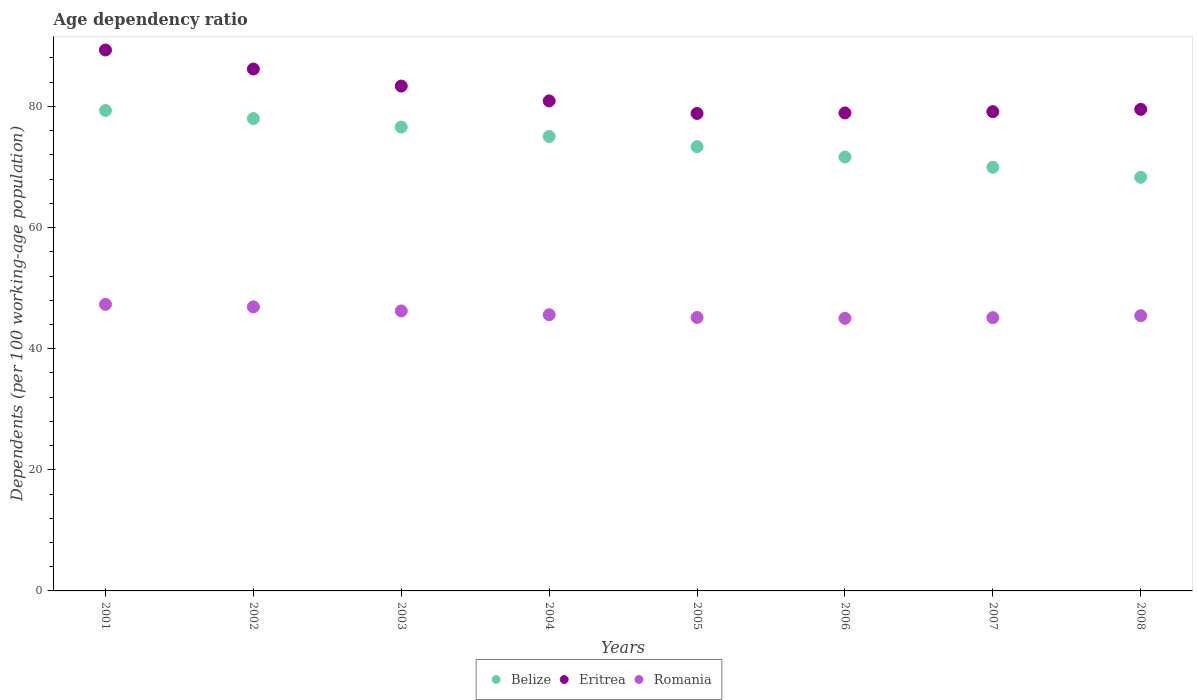How many different coloured dotlines are there?
Provide a short and direct response. 3. What is the age dependency ratio in in Eritrea in 2001?
Provide a succinct answer. 89.32. Across all years, what is the maximum age dependency ratio in in Eritrea?
Offer a very short reply. 89.32. Across all years, what is the minimum age dependency ratio in in Eritrea?
Offer a terse response. 78.84. In which year was the age dependency ratio in in Romania minimum?
Ensure brevity in your answer.  2006. What is the total age dependency ratio in in Romania in the graph?
Offer a terse response. 366.78. What is the difference between the age dependency ratio in in Belize in 2003 and that in 2005?
Your answer should be compact. 3.24. What is the difference between the age dependency ratio in in Romania in 2005 and the age dependency ratio in in Belize in 2008?
Provide a short and direct response. -23.15. What is the average age dependency ratio in in Romania per year?
Your response must be concise. 45.85. In the year 2008, what is the difference between the age dependency ratio in in Romania and age dependency ratio in in Belize?
Your response must be concise. -22.85. What is the ratio of the age dependency ratio in in Belize in 2005 to that in 2007?
Offer a terse response. 1.05. Is the age dependency ratio in in Romania in 2001 less than that in 2007?
Make the answer very short. No. What is the difference between the highest and the second highest age dependency ratio in in Romania?
Give a very brief answer. 0.43. What is the difference between the highest and the lowest age dependency ratio in in Romania?
Ensure brevity in your answer.  2.32. Is the sum of the age dependency ratio in in Romania in 2004 and 2008 greater than the maximum age dependency ratio in in Eritrea across all years?
Ensure brevity in your answer.  Yes. Does the age dependency ratio in in Belize monotonically increase over the years?
Ensure brevity in your answer.  No. Is the age dependency ratio in in Eritrea strictly less than the age dependency ratio in in Romania over the years?
Provide a succinct answer. No. How many dotlines are there?
Your answer should be compact. 3. How many years are there in the graph?
Give a very brief answer. 8. What is the difference between two consecutive major ticks on the Y-axis?
Offer a very short reply. 20. Does the graph contain any zero values?
Provide a succinct answer. No. Does the graph contain grids?
Your answer should be compact. No. How many legend labels are there?
Your answer should be compact. 3. How are the legend labels stacked?
Provide a short and direct response. Horizontal. What is the title of the graph?
Your answer should be compact. Age dependency ratio. What is the label or title of the X-axis?
Give a very brief answer. Years. What is the label or title of the Y-axis?
Your answer should be very brief. Dependents (per 100 working-age population). What is the Dependents (per 100 working-age population) in Belize in 2001?
Keep it short and to the point. 79.32. What is the Dependents (per 100 working-age population) in Eritrea in 2001?
Your answer should be compact. 89.32. What is the Dependents (per 100 working-age population) of Romania in 2001?
Make the answer very short. 47.32. What is the Dependents (per 100 working-age population) in Belize in 2002?
Provide a short and direct response. 77.99. What is the Dependents (per 100 working-age population) of Eritrea in 2002?
Ensure brevity in your answer.  86.18. What is the Dependents (per 100 working-age population) of Romania in 2002?
Offer a terse response. 46.9. What is the Dependents (per 100 working-age population) of Belize in 2003?
Your response must be concise. 76.59. What is the Dependents (per 100 working-age population) of Eritrea in 2003?
Make the answer very short. 83.36. What is the Dependents (per 100 working-age population) in Romania in 2003?
Your answer should be compact. 46.23. What is the Dependents (per 100 working-age population) in Belize in 2004?
Provide a succinct answer. 75.04. What is the Dependents (per 100 working-age population) in Eritrea in 2004?
Provide a short and direct response. 80.91. What is the Dependents (per 100 working-age population) of Romania in 2004?
Provide a short and direct response. 45.61. What is the Dependents (per 100 working-age population) in Belize in 2005?
Offer a very short reply. 73.35. What is the Dependents (per 100 working-age population) of Eritrea in 2005?
Your answer should be very brief. 78.84. What is the Dependents (per 100 working-age population) in Romania in 2005?
Offer a terse response. 45.15. What is the Dependents (per 100 working-age population) in Belize in 2006?
Offer a terse response. 71.64. What is the Dependents (per 100 working-age population) in Eritrea in 2006?
Your answer should be compact. 78.92. What is the Dependents (per 100 working-age population) in Romania in 2006?
Provide a succinct answer. 45. What is the Dependents (per 100 working-age population) in Belize in 2007?
Give a very brief answer. 69.95. What is the Dependents (per 100 working-age population) in Eritrea in 2007?
Keep it short and to the point. 79.14. What is the Dependents (per 100 working-age population) in Romania in 2007?
Your response must be concise. 45.12. What is the Dependents (per 100 working-age population) of Belize in 2008?
Keep it short and to the point. 68.3. What is the Dependents (per 100 working-age population) in Eritrea in 2008?
Your response must be concise. 79.51. What is the Dependents (per 100 working-age population) of Romania in 2008?
Your answer should be compact. 45.45. Across all years, what is the maximum Dependents (per 100 working-age population) in Belize?
Your answer should be very brief. 79.32. Across all years, what is the maximum Dependents (per 100 working-age population) of Eritrea?
Provide a short and direct response. 89.32. Across all years, what is the maximum Dependents (per 100 working-age population) in Romania?
Offer a terse response. 47.32. Across all years, what is the minimum Dependents (per 100 working-age population) in Belize?
Ensure brevity in your answer.  68.3. Across all years, what is the minimum Dependents (per 100 working-age population) in Eritrea?
Provide a succinct answer. 78.84. Across all years, what is the minimum Dependents (per 100 working-age population) in Romania?
Your answer should be very brief. 45. What is the total Dependents (per 100 working-age population) of Belize in the graph?
Your answer should be compact. 592.2. What is the total Dependents (per 100 working-age population) of Eritrea in the graph?
Give a very brief answer. 656.19. What is the total Dependents (per 100 working-age population) of Romania in the graph?
Provide a succinct answer. 366.78. What is the difference between the Dependents (per 100 working-age population) in Belize in 2001 and that in 2002?
Your response must be concise. 1.33. What is the difference between the Dependents (per 100 working-age population) in Eritrea in 2001 and that in 2002?
Offer a very short reply. 3.14. What is the difference between the Dependents (per 100 working-age population) of Romania in 2001 and that in 2002?
Offer a very short reply. 0.43. What is the difference between the Dependents (per 100 working-age population) in Belize in 2001 and that in 2003?
Your response must be concise. 2.73. What is the difference between the Dependents (per 100 working-age population) of Eritrea in 2001 and that in 2003?
Your answer should be very brief. 5.96. What is the difference between the Dependents (per 100 working-age population) of Romania in 2001 and that in 2003?
Offer a very short reply. 1.09. What is the difference between the Dependents (per 100 working-age population) in Belize in 2001 and that in 2004?
Your answer should be compact. 4.28. What is the difference between the Dependents (per 100 working-age population) in Eritrea in 2001 and that in 2004?
Your response must be concise. 8.41. What is the difference between the Dependents (per 100 working-age population) in Romania in 2001 and that in 2004?
Ensure brevity in your answer.  1.72. What is the difference between the Dependents (per 100 working-age population) of Belize in 2001 and that in 2005?
Your answer should be compact. 5.97. What is the difference between the Dependents (per 100 working-age population) in Eritrea in 2001 and that in 2005?
Your answer should be very brief. 10.48. What is the difference between the Dependents (per 100 working-age population) in Romania in 2001 and that in 2005?
Provide a succinct answer. 2.17. What is the difference between the Dependents (per 100 working-age population) of Belize in 2001 and that in 2006?
Ensure brevity in your answer.  7.68. What is the difference between the Dependents (per 100 working-age population) of Eritrea in 2001 and that in 2006?
Make the answer very short. 10.39. What is the difference between the Dependents (per 100 working-age population) in Romania in 2001 and that in 2006?
Offer a terse response. 2.32. What is the difference between the Dependents (per 100 working-age population) of Belize in 2001 and that in 2007?
Ensure brevity in your answer.  9.37. What is the difference between the Dependents (per 100 working-age population) in Eritrea in 2001 and that in 2007?
Ensure brevity in your answer.  10.18. What is the difference between the Dependents (per 100 working-age population) of Romania in 2001 and that in 2007?
Give a very brief answer. 2.2. What is the difference between the Dependents (per 100 working-age population) in Belize in 2001 and that in 2008?
Your response must be concise. 11.02. What is the difference between the Dependents (per 100 working-age population) in Eritrea in 2001 and that in 2008?
Provide a short and direct response. 9.81. What is the difference between the Dependents (per 100 working-age population) in Romania in 2001 and that in 2008?
Offer a very short reply. 1.88. What is the difference between the Dependents (per 100 working-age population) of Belize in 2002 and that in 2003?
Offer a terse response. 1.4. What is the difference between the Dependents (per 100 working-age population) in Eritrea in 2002 and that in 2003?
Provide a succinct answer. 2.82. What is the difference between the Dependents (per 100 working-age population) of Romania in 2002 and that in 2003?
Keep it short and to the point. 0.66. What is the difference between the Dependents (per 100 working-age population) of Belize in 2002 and that in 2004?
Your answer should be compact. 2.95. What is the difference between the Dependents (per 100 working-age population) in Eritrea in 2002 and that in 2004?
Offer a terse response. 5.26. What is the difference between the Dependents (per 100 working-age population) in Romania in 2002 and that in 2004?
Your answer should be very brief. 1.29. What is the difference between the Dependents (per 100 working-age population) of Belize in 2002 and that in 2005?
Offer a terse response. 4.64. What is the difference between the Dependents (per 100 working-age population) of Eritrea in 2002 and that in 2005?
Make the answer very short. 7.34. What is the difference between the Dependents (per 100 working-age population) in Romania in 2002 and that in 2005?
Make the answer very short. 1.75. What is the difference between the Dependents (per 100 working-age population) of Belize in 2002 and that in 2006?
Provide a short and direct response. 6.35. What is the difference between the Dependents (per 100 working-age population) of Eritrea in 2002 and that in 2006?
Provide a succinct answer. 7.25. What is the difference between the Dependents (per 100 working-age population) in Romania in 2002 and that in 2006?
Your answer should be compact. 1.89. What is the difference between the Dependents (per 100 working-age population) in Belize in 2002 and that in 2007?
Provide a succinct answer. 8.05. What is the difference between the Dependents (per 100 working-age population) in Eritrea in 2002 and that in 2007?
Provide a short and direct response. 7.04. What is the difference between the Dependents (per 100 working-age population) of Romania in 2002 and that in 2007?
Offer a very short reply. 1.78. What is the difference between the Dependents (per 100 working-age population) in Belize in 2002 and that in 2008?
Your answer should be very brief. 9.7. What is the difference between the Dependents (per 100 working-age population) in Eritrea in 2002 and that in 2008?
Your answer should be very brief. 6.67. What is the difference between the Dependents (per 100 working-age population) in Romania in 2002 and that in 2008?
Provide a succinct answer. 1.45. What is the difference between the Dependents (per 100 working-age population) of Belize in 2003 and that in 2004?
Keep it short and to the point. 1.55. What is the difference between the Dependents (per 100 working-age population) in Eritrea in 2003 and that in 2004?
Offer a terse response. 2.45. What is the difference between the Dependents (per 100 working-age population) in Romania in 2003 and that in 2004?
Ensure brevity in your answer.  0.63. What is the difference between the Dependents (per 100 working-age population) in Belize in 2003 and that in 2005?
Your answer should be very brief. 3.24. What is the difference between the Dependents (per 100 working-age population) of Eritrea in 2003 and that in 2005?
Your answer should be very brief. 4.52. What is the difference between the Dependents (per 100 working-age population) of Romania in 2003 and that in 2005?
Make the answer very short. 1.08. What is the difference between the Dependents (per 100 working-age population) of Belize in 2003 and that in 2006?
Ensure brevity in your answer.  4.95. What is the difference between the Dependents (per 100 working-age population) in Eritrea in 2003 and that in 2006?
Provide a short and direct response. 4.44. What is the difference between the Dependents (per 100 working-age population) of Romania in 2003 and that in 2006?
Give a very brief answer. 1.23. What is the difference between the Dependents (per 100 working-age population) of Belize in 2003 and that in 2007?
Offer a very short reply. 6.65. What is the difference between the Dependents (per 100 working-age population) of Eritrea in 2003 and that in 2007?
Provide a short and direct response. 4.22. What is the difference between the Dependents (per 100 working-age population) of Romania in 2003 and that in 2007?
Your response must be concise. 1.11. What is the difference between the Dependents (per 100 working-age population) in Belize in 2003 and that in 2008?
Your answer should be very brief. 8.3. What is the difference between the Dependents (per 100 working-age population) in Eritrea in 2003 and that in 2008?
Your answer should be very brief. 3.85. What is the difference between the Dependents (per 100 working-age population) of Romania in 2003 and that in 2008?
Your answer should be compact. 0.79. What is the difference between the Dependents (per 100 working-age population) of Belize in 2004 and that in 2005?
Ensure brevity in your answer.  1.69. What is the difference between the Dependents (per 100 working-age population) of Eritrea in 2004 and that in 2005?
Your answer should be compact. 2.07. What is the difference between the Dependents (per 100 working-age population) in Romania in 2004 and that in 2005?
Offer a terse response. 0.45. What is the difference between the Dependents (per 100 working-age population) in Belize in 2004 and that in 2006?
Offer a very short reply. 3.4. What is the difference between the Dependents (per 100 working-age population) in Eritrea in 2004 and that in 2006?
Provide a short and direct response. 1.99. What is the difference between the Dependents (per 100 working-age population) of Romania in 2004 and that in 2006?
Offer a very short reply. 0.6. What is the difference between the Dependents (per 100 working-age population) of Belize in 2004 and that in 2007?
Make the answer very short. 5.1. What is the difference between the Dependents (per 100 working-age population) of Eritrea in 2004 and that in 2007?
Provide a succinct answer. 1.78. What is the difference between the Dependents (per 100 working-age population) of Romania in 2004 and that in 2007?
Your response must be concise. 0.48. What is the difference between the Dependents (per 100 working-age population) in Belize in 2004 and that in 2008?
Offer a terse response. 6.75. What is the difference between the Dependents (per 100 working-age population) of Eritrea in 2004 and that in 2008?
Keep it short and to the point. 1.4. What is the difference between the Dependents (per 100 working-age population) in Romania in 2004 and that in 2008?
Your answer should be compact. 0.16. What is the difference between the Dependents (per 100 working-age population) in Belize in 2005 and that in 2006?
Offer a terse response. 1.71. What is the difference between the Dependents (per 100 working-age population) in Eritrea in 2005 and that in 2006?
Offer a very short reply. -0.08. What is the difference between the Dependents (per 100 working-age population) of Romania in 2005 and that in 2006?
Make the answer very short. 0.15. What is the difference between the Dependents (per 100 working-age population) of Belize in 2005 and that in 2007?
Offer a terse response. 3.41. What is the difference between the Dependents (per 100 working-age population) of Eritrea in 2005 and that in 2007?
Give a very brief answer. -0.3. What is the difference between the Dependents (per 100 working-age population) in Romania in 2005 and that in 2007?
Offer a terse response. 0.03. What is the difference between the Dependents (per 100 working-age population) in Belize in 2005 and that in 2008?
Provide a short and direct response. 5.05. What is the difference between the Dependents (per 100 working-age population) in Eritrea in 2005 and that in 2008?
Provide a succinct answer. -0.67. What is the difference between the Dependents (per 100 working-age population) in Romania in 2005 and that in 2008?
Your answer should be very brief. -0.3. What is the difference between the Dependents (per 100 working-age population) of Belize in 2006 and that in 2007?
Your answer should be very brief. 1.7. What is the difference between the Dependents (per 100 working-age population) of Eritrea in 2006 and that in 2007?
Provide a short and direct response. -0.21. What is the difference between the Dependents (per 100 working-age population) in Romania in 2006 and that in 2007?
Your answer should be compact. -0.12. What is the difference between the Dependents (per 100 working-age population) in Belize in 2006 and that in 2008?
Offer a very short reply. 3.35. What is the difference between the Dependents (per 100 working-age population) in Eritrea in 2006 and that in 2008?
Your answer should be compact. -0.59. What is the difference between the Dependents (per 100 working-age population) in Romania in 2006 and that in 2008?
Provide a succinct answer. -0.44. What is the difference between the Dependents (per 100 working-age population) in Belize in 2007 and that in 2008?
Offer a very short reply. 1.65. What is the difference between the Dependents (per 100 working-age population) in Eritrea in 2007 and that in 2008?
Provide a succinct answer. -0.37. What is the difference between the Dependents (per 100 working-age population) in Romania in 2007 and that in 2008?
Give a very brief answer. -0.32. What is the difference between the Dependents (per 100 working-age population) in Belize in 2001 and the Dependents (per 100 working-age population) in Eritrea in 2002?
Your answer should be very brief. -6.86. What is the difference between the Dependents (per 100 working-age population) of Belize in 2001 and the Dependents (per 100 working-age population) of Romania in 2002?
Provide a succinct answer. 32.42. What is the difference between the Dependents (per 100 working-age population) in Eritrea in 2001 and the Dependents (per 100 working-age population) in Romania in 2002?
Ensure brevity in your answer.  42.42. What is the difference between the Dependents (per 100 working-age population) in Belize in 2001 and the Dependents (per 100 working-age population) in Eritrea in 2003?
Make the answer very short. -4.04. What is the difference between the Dependents (per 100 working-age population) of Belize in 2001 and the Dependents (per 100 working-age population) of Romania in 2003?
Keep it short and to the point. 33.09. What is the difference between the Dependents (per 100 working-age population) of Eritrea in 2001 and the Dependents (per 100 working-age population) of Romania in 2003?
Provide a short and direct response. 43.09. What is the difference between the Dependents (per 100 working-age population) of Belize in 2001 and the Dependents (per 100 working-age population) of Eritrea in 2004?
Your answer should be compact. -1.59. What is the difference between the Dependents (per 100 working-age population) in Belize in 2001 and the Dependents (per 100 working-age population) in Romania in 2004?
Your answer should be very brief. 33.72. What is the difference between the Dependents (per 100 working-age population) of Eritrea in 2001 and the Dependents (per 100 working-age population) of Romania in 2004?
Provide a short and direct response. 43.71. What is the difference between the Dependents (per 100 working-age population) in Belize in 2001 and the Dependents (per 100 working-age population) in Eritrea in 2005?
Offer a terse response. 0.48. What is the difference between the Dependents (per 100 working-age population) in Belize in 2001 and the Dependents (per 100 working-age population) in Romania in 2005?
Ensure brevity in your answer.  34.17. What is the difference between the Dependents (per 100 working-age population) of Eritrea in 2001 and the Dependents (per 100 working-age population) of Romania in 2005?
Offer a terse response. 44.17. What is the difference between the Dependents (per 100 working-age population) of Belize in 2001 and the Dependents (per 100 working-age population) of Eritrea in 2006?
Ensure brevity in your answer.  0.4. What is the difference between the Dependents (per 100 working-age population) of Belize in 2001 and the Dependents (per 100 working-age population) of Romania in 2006?
Offer a terse response. 34.32. What is the difference between the Dependents (per 100 working-age population) in Eritrea in 2001 and the Dependents (per 100 working-age population) in Romania in 2006?
Provide a succinct answer. 44.31. What is the difference between the Dependents (per 100 working-age population) of Belize in 2001 and the Dependents (per 100 working-age population) of Eritrea in 2007?
Provide a short and direct response. 0.18. What is the difference between the Dependents (per 100 working-age population) of Belize in 2001 and the Dependents (per 100 working-age population) of Romania in 2007?
Provide a short and direct response. 34.2. What is the difference between the Dependents (per 100 working-age population) in Eritrea in 2001 and the Dependents (per 100 working-age population) in Romania in 2007?
Make the answer very short. 44.2. What is the difference between the Dependents (per 100 working-age population) of Belize in 2001 and the Dependents (per 100 working-age population) of Eritrea in 2008?
Offer a very short reply. -0.19. What is the difference between the Dependents (per 100 working-age population) in Belize in 2001 and the Dependents (per 100 working-age population) in Romania in 2008?
Your answer should be very brief. 33.87. What is the difference between the Dependents (per 100 working-age population) in Eritrea in 2001 and the Dependents (per 100 working-age population) in Romania in 2008?
Offer a very short reply. 43.87. What is the difference between the Dependents (per 100 working-age population) of Belize in 2002 and the Dependents (per 100 working-age population) of Eritrea in 2003?
Your answer should be very brief. -5.37. What is the difference between the Dependents (per 100 working-age population) of Belize in 2002 and the Dependents (per 100 working-age population) of Romania in 2003?
Provide a short and direct response. 31.76. What is the difference between the Dependents (per 100 working-age population) of Eritrea in 2002 and the Dependents (per 100 working-age population) of Romania in 2003?
Your answer should be very brief. 39.94. What is the difference between the Dependents (per 100 working-age population) in Belize in 2002 and the Dependents (per 100 working-age population) in Eritrea in 2004?
Your answer should be compact. -2.92. What is the difference between the Dependents (per 100 working-age population) of Belize in 2002 and the Dependents (per 100 working-age population) of Romania in 2004?
Your response must be concise. 32.39. What is the difference between the Dependents (per 100 working-age population) of Eritrea in 2002 and the Dependents (per 100 working-age population) of Romania in 2004?
Your answer should be very brief. 40.57. What is the difference between the Dependents (per 100 working-age population) in Belize in 2002 and the Dependents (per 100 working-age population) in Eritrea in 2005?
Ensure brevity in your answer.  -0.85. What is the difference between the Dependents (per 100 working-age population) of Belize in 2002 and the Dependents (per 100 working-age population) of Romania in 2005?
Your answer should be very brief. 32.84. What is the difference between the Dependents (per 100 working-age population) in Eritrea in 2002 and the Dependents (per 100 working-age population) in Romania in 2005?
Ensure brevity in your answer.  41.03. What is the difference between the Dependents (per 100 working-age population) in Belize in 2002 and the Dependents (per 100 working-age population) in Eritrea in 2006?
Ensure brevity in your answer.  -0.93. What is the difference between the Dependents (per 100 working-age population) in Belize in 2002 and the Dependents (per 100 working-age population) in Romania in 2006?
Provide a short and direct response. 32.99. What is the difference between the Dependents (per 100 working-age population) in Eritrea in 2002 and the Dependents (per 100 working-age population) in Romania in 2006?
Give a very brief answer. 41.17. What is the difference between the Dependents (per 100 working-age population) in Belize in 2002 and the Dependents (per 100 working-age population) in Eritrea in 2007?
Offer a very short reply. -1.14. What is the difference between the Dependents (per 100 working-age population) of Belize in 2002 and the Dependents (per 100 working-age population) of Romania in 2007?
Offer a terse response. 32.87. What is the difference between the Dependents (per 100 working-age population) in Eritrea in 2002 and the Dependents (per 100 working-age population) in Romania in 2007?
Your answer should be compact. 41.06. What is the difference between the Dependents (per 100 working-age population) of Belize in 2002 and the Dependents (per 100 working-age population) of Eritrea in 2008?
Your answer should be compact. -1.52. What is the difference between the Dependents (per 100 working-age population) in Belize in 2002 and the Dependents (per 100 working-age population) in Romania in 2008?
Offer a terse response. 32.55. What is the difference between the Dependents (per 100 working-age population) of Eritrea in 2002 and the Dependents (per 100 working-age population) of Romania in 2008?
Your answer should be very brief. 40.73. What is the difference between the Dependents (per 100 working-age population) in Belize in 2003 and the Dependents (per 100 working-age population) in Eritrea in 2004?
Keep it short and to the point. -4.32. What is the difference between the Dependents (per 100 working-age population) of Belize in 2003 and the Dependents (per 100 working-age population) of Romania in 2004?
Your response must be concise. 30.99. What is the difference between the Dependents (per 100 working-age population) in Eritrea in 2003 and the Dependents (per 100 working-age population) in Romania in 2004?
Ensure brevity in your answer.  37.76. What is the difference between the Dependents (per 100 working-age population) of Belize in 2003 and the Dependents (per 100 working-age population) of Eritrea in 2005?
Provide a succinct answer. -2.25. What is the difference between the Dependents (per 100 working-age population) in Belize in 2003 and the Dependents (per 100 working-age population) in Romania in 2005?
Keep it short and to the point. 31.44. What is the difference between the Dependents (per 100 working-age population) of Eritrea in 2003 and the Dependents (per 100 working-age population) of Romania in 2005?
Offer a very short reply. 38.21. What is the difference between the Dependents (per 100 working-age population) in Belize in 2003 and the Dependents (per 100 working-age population) in Eritrea in 2006?
Your answer should be compact. -2.33. What is the difference between the Dependents (per 100 working-age population) of Belize in 2003 and the Dependents (per 100 working-age population) of Romania in 2006?
Give a very brief answer. 31.59. What is the difference between the Dependents (per 100 working-age population) in Eritrea in 2003 and the Dependents (per 100 working-age population) in Romania in 2006?
Keep it short and to the point. 38.36. What is the difference between the Dependents (per 100 working-age population) in Belize in 2003 and the Dependents (per 100 working-age population) in Eritrea in 2007?
Make the answer very short. -2.54. What is the difference between the Dependents (per 100 working-age population) in Belize in 2003 and the Dependents (per 100 working-age population) in Romania in 2007?
Your response must be concise. 31.47. What is the difference between the Dependents (per 100 working-age population) in Eritrea in 2003 and the Dependents (per 100 working-age population) in Romania in 2007?
Provide a short and direct response. 38.24. What is the difference between the Dependents (per 100 working-age population) in Belize in 2003 and the Dependents (per 100 working-age population) in Eritrea in 2008?
Ensure brevity in your answer.  -2.92. What is the difference between the Dependents (per 100 working-age population) in Belize in 2003 and the Dependents (per 100 working-age population) in Romania in 2008?
Your answer should be compact. 31.15. What is the difference between the Dependents (per 100 working-age population) of Eritrea in 2003 and the Dependents (per 100 working-age population) of Romania in 2008?
Your answer should be very brief. 37.91. What is the difference between the Dependents (per 100 working-age population) of Belize in 2004 and the Dependents (per 100 working-age population) of Eritrea in 2005?
Provide a succinct answer. -3.8. What is the difference between the Dependents (per 100 working-age population) of Belize in 2004 and the Dependents (per 100 working-age population) of Romania in 2005?
Ensure brevity in your answer.  29.89. What is the difference between the Dependents (per 100 working-age population) in Eritrea in 2004 and the Dependents (per 100 working-age population) in Romania in 2005?
Your answer should be very brief. 35.76. What is the difference between the Dependents (per 100 working-age population) of Belize in 2004 and the Dependents (per 100 working-age population) of Eritrea in 2006?
Offer a terse response. -3.88. What is the difference between the Dependents (per 100 working-age population) of Belize in 2004 and the Dependents (per 100 working-age population) of Romania in 2006?
Ensure brevity in your answer.  30.04. What is the difference between the Dependents (per 100 working-age population) of Eritrea in 2004 and the Dependents (per 100 working-age population) of Romania in 2006?
Your response must be concise. 35.91. What is the difference between the Dependents (per 100 working-age population) in Belize in 2004 and the Dependents (per 100 working-age population) in Eritrea in 2007?
Make the answer very short. -4.09. What is the difference between the Dependents (per 100 working-age population) in Belize in 2004 and the Dependents (per 100 working-age population) in Romania in 2007?
Your answer should be compact. 29.92. What is the difference between the Dependents (per 100 working-age population) in Eritrea in 2004 and the Dependents (per 100 working-age population) in Romania in 2007?
Provide a short and direct response. 35.79. What is the difference between the Dependents (per 100 working-age population) of Belize in 2004 and the Dependents (per 100 working-age population) of Eritrea in 2008?
Give a very brief answer. -4.47. What is the difference between the Dependents (per 100 working-age population) of Belize in 2004 and the Dependents (per 100 working-age population) of Romania in 2008?
Your answer should be very brief. 29.6. What is the difference between the Dependents (per 100 working-age population) in Eritrea in 2004 and the Dependents (per 100 working-age population) in Romania in 2008?
Give a very brief answer. 35.47. What is the difference between the Dependents (per 100 working-age population) of Belize in 2005 and the Dependents (per 100 working-age population) of Eritrea in 2006?
Your answer should be very brief. -5.57. What is the difference between the Dependents (per 100 working-age population) in Belize in 2005 and the Dependents (per 100 working-age population) in Romania in 2006?
Provide a succinct answer. 28.35. What is the difference between the Dependents (per 100 working-age population) in Eritrea in 2005 and the Dependents (per 100 working-age population) in Romania in 2006?
Keep it short and to the point. 33.84. What is the difference between the Dependents (per 100 working-age population) of Belize in 2005 and the Dependents (per 100 working-age population) of Eritrea in 2007?
Your answer should be very brief. -5.78. What is the difference between the Dependents (per 100 working-age population) in Belize in 2005 and the Dependents (per 100 working-age population) in Romania in 2007?
Offer a terse response. 28.23. What is the difference between the Dependents (per 100 working-age population) in Eritrea in 2005 and the Dependents (per 100 working-age population) in Romania in 2007?
Ensure brevity in your answer.  33.72. What is the difference between the Dependents (per 100 working-age population) in Belize in 2005 and the Dependents (per 100 working-age population) in Eritrea in 2008?
Offer a very short reply. -6.16. What is the difference between the Dependents (per 100 working-age population) in Belize in 2005 and the Dependents (per 100 working-age population) in Romania in 2008?
Offer a terse response. 27.91. What is the difference between the Dependents (per 100 working-age population) of Eritrea in 2005 and the Dependents (per 100 working-age population) of Romania in 2008?
Ensure brevity in your answer.  33.39. What is the difference between the Dependents (per 100 working-age population) of Belize in 2006 and the Dependents (per 100 working-age population) of Eritrea in 2007?
Offer a terse response. -7.49. What is the difference between the Dependents (per 100 working-age population) of Belize in 2006 and the Dependents (per 100 working-age population) of Romania in 2007?
Your answer should be very brief. 26.52. What is the difference between the Dependents (per 100 working-age population) in Eritrea in 2006 and the Dependents (per 100 working-age population) in Romania in 2007?
Your answer should be compact. 33.8. What is the difference between the Dependents (per 100 working-age population) of Belize in 2006 and the Dependents (per 100 working-age population) of Eritrea in 2008?
Offer a terse response. -7.87. What is the difference between the Dependents (per 100 working-age population) in Belize in 2006 and the Dependents (per 100 working-age population) in Romania in 2008?
Keep it short and to the point. 26.2. What is the difference between the Dependents (per 100 working-age population) of Eritrea in 2006 and the Dependents (per 100 working-age population) of Romania in 2008?
Your response must be concise. 33.48. What is the difference between the Dependents (per 100 working-age population) of Belize in 2007 and the Dependents (per 100 working-age population) of Eritrea in 2008?
Make the answer very short. -9.57. What is the difference between the Dependents (per 100 working-age population) in Belize in 2007 and the Dependents (per 100 working-age population) in Romania in 2008?
Your answer should be compact. 24.5. What is the difference between the Dependents (per 100 working-age population) in Eritrea in 2007 and the Dependents (per 100 working-age population) in Romania in 2008?
Provide a succinct answer. 33.69. What is the average Dependents (per 100 working-age population) of Belize per year?
Provide a succinct answer. 74.02. What is the average Dependents (per 100 working-age population) of Eritrea per year?
Provide a short and direct response. 82.02. What is the average Dependents (per 100 working-age population) in Romania per year?
Make the answer very short. 45.85. In the year 2001, what is the difference between the Dependents (per 100 working-age population) in Belize and Dependents (per 100 working-age population) in Eritrea?
Ensure brevity in your answer.  -10. In the year 2001, what is the difference between the Dependents (per 100 working-age population) of Belize and Dependents (per 100 working-age population) of Romania?
Provide a succinct answer. 32. In the year 2001, what is the difference between the Dependents (per 100 working-age population) in Eritrea and Dependents (per 100 working-age population) in Romania?
Your answer should be very brief. 41.99. In the year 2002, what is the difference between the Dependents (per 100 working-age population) in Belize and Dependents (per 100 working-age population) in Eritrea?
Make the answer very short. -8.18. In the year 2002, what is the difference between the Dependents (per 100 working-age population) of Belize and Dependents (per 100 working-age population) of Romania?
Provide a succinct answer. 31.1. In the year 2002, what is the difference between the Dependents (per 100 working-age population) in Eritrea and Dependents (per 100 working-age population) in Romania?
Keep it short and to the point. 39.28. In the year 2003, what is the difference between the Dependents (per 100 working-age population) in Belize and Dependents (per 100 working-age population) in Eritrea?
Offer a terse response. -6.77. In the year 2003, what is the difference between the Dependents (per 100 working-age population) in Belize and Dependents (per 100 working-age population) in Romania?
Offer a terse response. 30.36. In the year 2003, what is the difference between the Dependents (per 100 working-age population) in Eritrea and Dependents (per 100 working-age population) in Romania?
Ensure brevity in your answer.  37.13. In the year 2004, what is the difference between the Dependents (per 100 working-age population) of Belize and Dependents (per 100 working-age population) of Eritrea?
Your answer should be compact. -5.87. In the year 2004, what is the difference between the Dependents (per 100 working-age population) in Belize and Dependents (per 100 working-age population) in Romania?
Offer a very short reply. 29.44. In the year 2004, what is the difference between the Dependents (per 100 working-age population) of Eritrea and Dependents (per 100 working-age population) of Romania?
Provide a short and direct response. 35.31. In the year 2005, what is the difference between the Dependents (per 100 working-age population) of Belize and Dependents (per 100 working-age population) of Eritrea?
Make the answer very short. -5.49. In the year 2005, what is the difference between the Dependents (per 100 working-age population) in Belize and Dependents (per 100 working-age population) in Romania?
Provide a succinct answer. 28.2. In the year 2005, what is the difference between the Dependents (per 100 working-age population) of Eritrea and Dependents (per 100 working-age population) of Romania?
Ensure brevity in your answer.  33.69. In the year 2006, what is the difference between the Dependents (per 100 working-age population) of Belize and Dependents (per 100 working-age population) of Eritrea?
Ensure brevity in your answer.  -7.28. In the year 2006, what is the difference between the Dependents (per 100 working-age population) in Belize and Dependents (per 100 working-age population) in Romania?
Your answer should be compact. 26.64. In the year 2006, what is the difference between the Dependents (per 100 working-age population) of Eritrea and Dependents (per 100 working-age population) of Romania?
Your answer should be very brief. 33.92. In the year 2007, what is the difference between the Dependents (per 100 working-age population) of Belize and Dependents (per 100 working-age population) of Eritrea?
Ensure brevity in your answer.  -9.19. In the year 2007, what is the difference between the Dependents (per 100 working-age population) of Belize and Dependents (per 100 working-age population) of Romania?
Provide a short and direct response. 24.83. In the year 2007, what is the difference between the Dependents (per 100 working-age population) in Eritrea and Dependents (per 100 working-age population) in Romania?
Your response must be concise. 34.02. In the year 2008, what is the difference between the Dependents (per 100 working-age population) of Belize and Dependents (per 100 working-age population) of Eritrea?
Keep it short and to the point. -11.21. In the year 2008, what is the difference between the Dependents (per 100 working-age population) in Belize and Dependents (per 100 working-age population) in Romania?
Make the answer very short. 22.85. In the year 2008, what is the difference between the Dependents (per 100 working-age population) of Eritrea and Dependents (per 100 working-age population) of Romania?
Your answer should be very brief. 34.07. What is the ratio of the Dependents (per 100 working-age population) of Belize in 2001 to that in 2002?
Your answer should be very brief. 1.02. What is the ratio of the Dependents (per 100 working-age population) in Eritrea in 2001 to that in 2002?
Your response must be concise. 1.04. What is the ratio of the Dependents (per 100 working-age population) of Romania in 2001 to that in 2002?
Provide a succinct answer. 1.01. What is the ratio of the Dependents (per 100 working-age population) of Belize in 2001 to that in 2003?
Make the answer very short. 1.04. What is the ratio of the Dependents (per 100 working-age population) of Eritrea in 2001 to that in 2003?
Make the answer very short. 1.07. What is the ratio of the Dependents (per 100 working-age population) in Romania in 2001 to that in 2003?
Your answer should be very brief. 1.02. What is the ratio of the Dependents (per 100 working-age population) in Belize in 2001 to that in 2004?
Give a very brief answer. 1.06. What is the ratio of the Dependents (per 100 working-age population) in Eritrea in 2001 to that in 2004?
Provide a short and direct response. 1.1. What is the ratio of the Dependents (per 100 working-age population) of Romania in 2001 to that in 2004?
Offer a very short reply. 1.04. What is the ratio of the Dependents (per 100 working-age population) of Belize in 2001 to that in 2005?
Offer a terse response. 1.08. What is the ratio of the Dependents (per 100 working-age population) of Eritrea in 2001 to that in 2005?
Your answer should be compact. 1.13. What is the ratio of the Dependents (per 100 working-age population) in Romania in 2001 to that in 2005?
Offer a terse response. 1.05. What is the ratio of the Dependents (per 100 working-age population) in Belize in 2001 to that in 2006?
Provide a short and direct response. 1.11. What is the ratio of the Dependents (per 100 working-age population) in Eritrea in 2001 to that in 2006?
Ensure brevity in your answer.  1.13. What is the ratio of the Dependents (per 100 working-age population) of Romania in 2001 to that in 2006?
Provide a short and direct response. 1.05. What is the ratio of the Dependents (per 100 working-age population) of Belize in 2001 to that in 2007?
Your answer should be compact. 1.13. What is the ratio of the Dependents (per 100 working-age population) in Eritrea in 2001 to that in 2007?
Offer a very short reply. 1.13. What is the ratio of the Dependents (per 100 working-age population) of Romania in 2001 to that in 2007?
Give a very brief answer. 1.05. What is the ratio of the Dependents (per 100 working-age population) in Belize in 2001 to that in 2008?
Provide a succinct answer. 1.16. What is the ratio of the Dependents (per 100 working-age population) of Eritrea in 2001 to that in 2008?
Ensure brevity in your answer.  1.12. What is the ratio of the Dependents (per 100 working-age population) in Romania in 2001 to that in 2008?
Give a very brief answer. 1.04. What is the ratio of the Dependents (per 100 working-age population) in Belize in 2002 to that in 2003?
Offer a very short reply. 1.02. What is the ratio of the Dependents (per 100 working-age population) in Eritrea in 2002 to that in 2003?
Your answer should be very brief. 1.03. What is the ratio of the Dependents (per 100 working-age population) of Romania in 2002 to that in 2003?
Provide a succinct answer. 1.01. What is the ratio of the Dependents (per 100 working-age population) of Belize in 2002 to that in 2004?
Your answer should be very brief. 1.04. What is the ratio of the Dependents (per 100 working-age population) in Eritrea in 2002 to that in 2004?
Offer a terse response. 1.07. What is the ratio of the Dependents (per 100 working-age population) in Romania in 2002 to that in 2004?
Ensure brevity in your answer.  1.03. What is the ratio of the Dependents (per 100 working-age population) of Belize in 2002 to that in 2005?
Offer a terse response. 1.06. What is the ratio of the Dependents (per 100 working-age population) in Eritrea in 2002 to that in 2005?
Provide a succinct answer. 1.09. What is the ratio of the Dependents (per 100 working-age population) of Romania in 2002 to that in 2005?
Provide a short and direct response. 1.04. What is the ratio of the Dependents (per 100 working-age population) in Belize in 2002 to that in 2006?
Offer a terse response. 1.09. What is the ratio of the Dependents (per 100 working-age population) of Eritrea in 2002 to that in 2006?
Make the answer very short. 1.09. What is the ratio of the Dependents (per 100 working-age population) in Romania in 2002 to that in 2006?
Your answer should be very brief. 1.04. What is the ratio of the Dependents (per 100 working-age population) of Belize in 2002 to that in 2007?
Provide a short and direct response. 1.12. What is the ratio of the Dependents (per 100 working-age population) of Eritrea in 2002 to that in 2007?
Offer a very short reply. 1.09. What is the ratio of the Dependents (per 100 working-age population) of Romania in 2002 to that in 2007?
Provide a succinct answer. 1.04. What is the ratio of the Dependents (per 100 working-age population) in Belize in 2002 to that in 2008?
Your answer should be compact. 1.14. What is the ratio of the Dependents (per 100 working-age population) in Eritrea in 2002 to that in 2008?
Make the answer very short. 1.08. What is the ratio of the Dependents (per 100 working-age population) in Romania in 2002 to that in 2008?
Your answer should be very brief. 1.03. What is the ratio of the Dependents (per 100 working-age population) in Belize in 2003 to that in 2004?
Offer a very short reply. 1.02. What is the ratio of the Dependents (per 100 working-age population) of Eritrea in 2003 to that in 2004?
Provide a succinct answer. 1.03. What is the ratio of the Dependents (per 100 working-age population) in Romania in 2003 to that in 2004?
Offer a terse response. 1.01. What is the ratio of the Dependents (per 100 working-age population) of Belize in 2003 to that in 2005?
Your response must be concise. 1.04. What is the ratio of the Dependents (per 100 working-age population) in Eritrea in 2003 to that in 2005?
Keep it short and to the point. 1.06. What is the ratio of the Dependents (per 100 working-age population) of Belize in 2003 to that in 2006?
Your answer should be very brief. 1.07. What is the ratio of the Dependents (per 100 working-age population) in Eritrea in 2003 to that in 2006?
Your answer should be compact. 1.06. What is the ratio of the Dependents (per 100 working-age population) in Romania in 2003 to that in 2006?
Ensure brevity in your answer.  1.03. What is the ratio of the Dependents (per 100 working-age population) in Belize in 2003 to that in 2007?
Ensure brevity in your answer.  1.09. What is the ratio of the Dependents (per 100 working-age population) in Eritrea in 2003 to that in 2007?
Ensure brevity in your answer.  1.05. What is the ratio of the Dependents (per 100 working-age population) of Romania in 2003 to that in 2007?
Provide a short and direct response. 1.02. What is the ratio of the Dependents (per 100 working-age population) in Belize in 2003 to that in 2008?
Give a very brief answer. 1.12. What is the ratio of the Dependents (per 100 working-age population) in Eritrea in 2003 to that in 2008?
Your answer should be very brief. 1.05. What is the ratio of the Dependents (per 100 working-age population) of Romania in 2003 to that in 2008?
Give a very brief answer. 1.02. What is the ratio of the Dependents (per 100 working-age population) of Belize in 2004 to that in 2005?
Give a very brief answer. 1.02. What is the ratio of the Dependents (per 100 working-age population) in Eritrea in 2004 to that in 2005?
Your response must be concise. 1.03. What is the ratio of the Dependents (per 100 working-age population) of Belize in 2004 to that in 2006?
Your answer should be compact. 1.05. What is the ratio of the Dependents (per 100 working-age population) of Eritrea in 2004 to that in 2006?
Make the answer very short. 1.03. What is the ratio of the Dependents (per 100 working-age population) of Romania in 2004 to that in 2006?
Your answer should be very brief. 1.01. What is the ratio of the Dependents (per 100 working-age population) in Belize in 2004 to that in 2007?
Your answer should be very brief. 1.07. What is the ratio of the Dependents (per 100 working-age population) in Eritrea in 2004 to that in 2007?
Give a very brief answer. 1.02. What is the ratio of the Dependents (per 100 working-age population) in Romania in 2004 to that in 2007?
Your answer should be compact. 1.01. What is the ratio of the Dependents (per 100 working-age population) of Belize in 2004 to that in 2008?
Your response must be concise. 1.1. What is the ratio of the Dependents (per 100 working-age population) in Eritrea in 2004 to that in 2008?
Offer a very short reply. 1.02. What is the ratio of the Dependents (per 100 working-age population) of Romania in 2004 to that in 2008?
Keep it short and to the point. 1. What is the ratio of the Dependents (per 100 working-age population) in Belize in 2005 to that in 2006?
Give a very brief answer. 1.02. What is the ratio of the Dependents (per 100 working-age population) of Eritrea in 2005 to that in 2006?
Offer a terse response. 1. What is the ratio of the Dependents (per 100 working-age population) of Romania in 2005 to that in 2006?
Offer a terse response. 1. What is the ratio of the Dependents (per 100 working-age population) in Belize in 2005 to that in 2007?
Offer a terse response. 1.05. What is the ratio of the Dependents (per 100 working-age population) of Belize in 2005 to that in 2008?
Give a very brief answer. 1.07. What is the ratio of the Dependents (per 100 working-age population) of Eritrea in 2005 to that in 2008?
Your answer should be compact. 0.99. What is the ratio of the Dependents (per 100 working-age population) in Romania in 2005 to that in 2008?
Ensure brevity in your answer.  0.99. What is the ratio of the Dependents (per 100 working-age population) of Belize in 2006 to that in 2007?
Provide a succinct answer. 1.02. What is the ratio of the Dependents (per 100 working-age population) of Eritrea in 2006 to that in 2007?
Keep it short and to the point. 1. What is the ratio of the Dependents (per 100 working-age population) of Belize in 2006 to that in 2008?
Offer a terse response. 1.05. What is the ratio of the Dependents (per 100 working-age population) in Romania in 2006 to that in 2008?
Provide a short and direct response. 0.99. What is the ratio of the Dependents (per 100 working-age population) in Belize in 2007 to that in 2008?
Your answer should be compact. 1.02. What is the difference between the highest and the second highest Dependents (per 100 working-age population) of Belize?
Provide a short and direct response. 1.33. What is the difference between the highest and the second highest Dependents (per 100 working-age population) of Eritrea?
Make the answer very short. 3.14. What is the difference between the highest and the second highest Dependents (per 100 working-age population) in Romania?
Your response must be concise. 0.43. What is the difference between the highest and the lowest Dependents (per 100 working-age population) of Belize?
Ensure brevity in your answer.  11.02. What is the difference between the highest and the lowest Dependents (per 100 working-age population) of Eritrea?
Give a very brief answer. 10.48. What is the difference between the highest and the lowest Dependents (per 100 working-age population) of Romania?
Keep it short and to the point. 2.32. 